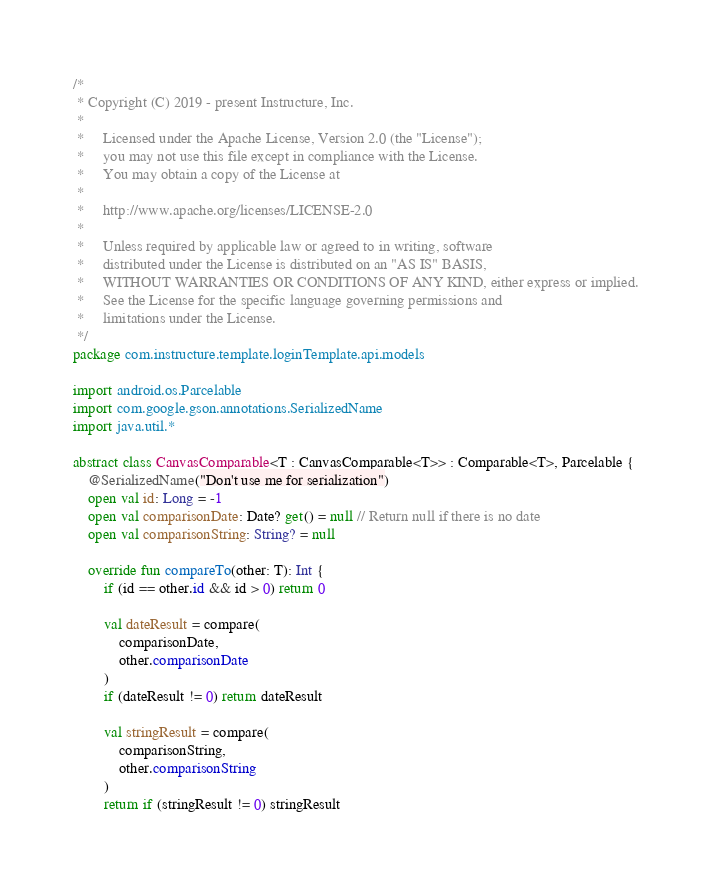<code> <loc_0><loc_0><loc_500><loc_500><_Kotlin_>/*
 * Copyright (C) 2019 - present Instructure, Inc.
 *
 *     Licensed under the Apache License, Version 2.0 (the "License");
 *     you may not use this file except in compliance with the License.
 *     You may obtain a copy of the License at
 *
 *     http://www.apache.org/licenses/LICENSE-2.0
 *
 *     Unless required by applicable law or agreed to in writing, software
 *     distributed under the License is distributed on an "AS IS" BASIS,
 *     WITHOUT WARRANTIES OR CONDITIONS OF ANY KIND, either express or implied.
 *     See the License for the specific language governing permissions and
 *     limitations under the License.
 */
package com.instructure.template.loginTemplate.api.models

import android.os.Parcelable
import com.google.gson.annotations.SerializedName
import java.util.*

abstract class CanvasComparable<T : CanvasComparable<T>> : Comparable<T>, Parcelable {
    @SerializedName("Don't use me for serialization")
    open val id: Long = -1
    open val comparisonDate: Date? get() = null // Return null if there is no date
    open val comparisonString: String? = null

    override fun compareTo(other: T): Int {
        if (id == other.id && id > 0) return 0

        val dateResult = compare(
            comparisonDate,
            other.comparisonDate
        )
        if (dateResult != 0) return dateResult

        val stringResult = compare(
            comparisonString,
            other.comparisonString
        )
        return if (stringResult != 0) stringResult</code> 